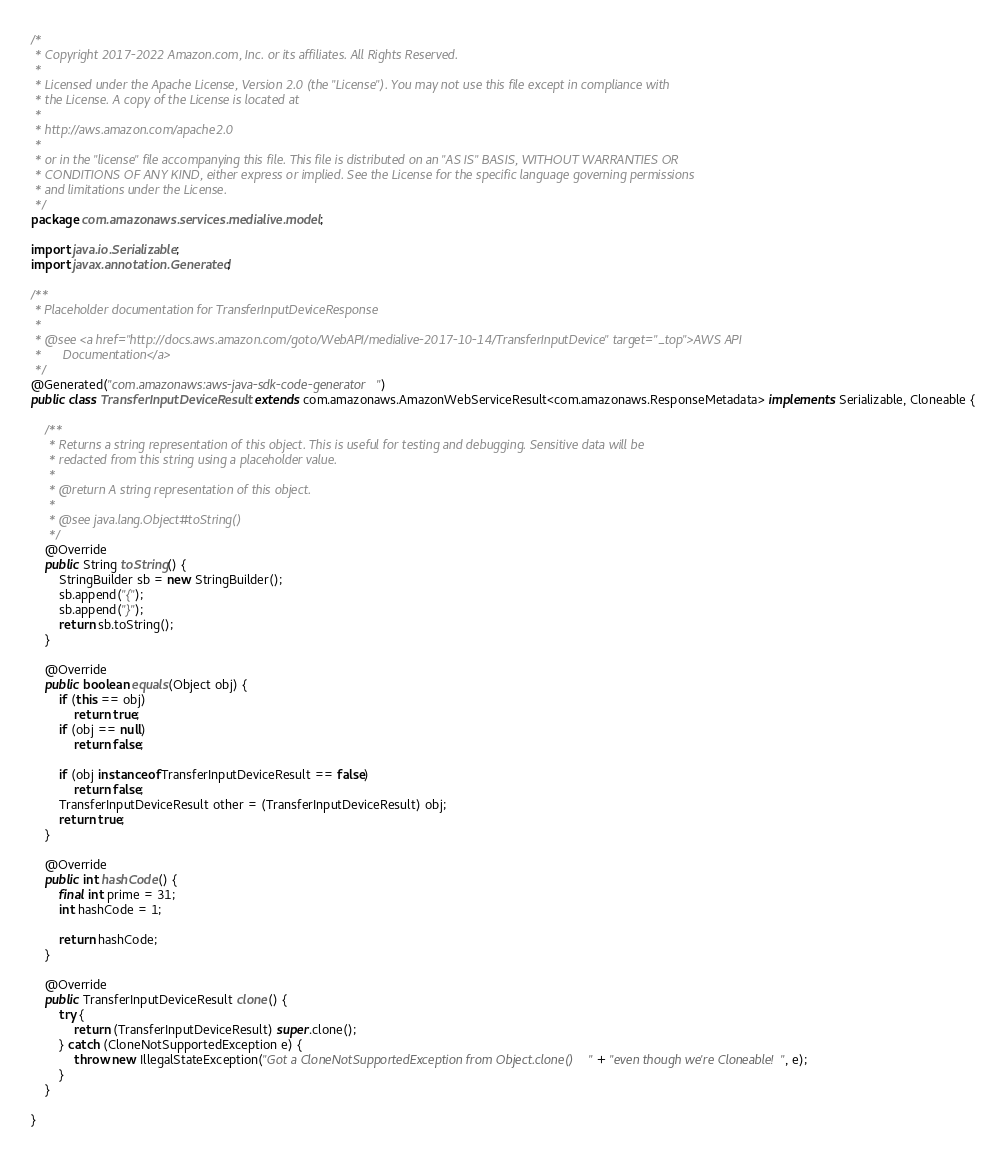<code> <loc_0><loc_0><loc_500><loc_500><_Java_>/*
 * Copyright 2017-2022 Amazon.com, Inc. or its affiliates. All Rights Reserved.
 * 
 * Licensed under the Apache License, Version 2.0 (the "License"). You may not use this file except in compliance with
 * the License. A copy of the License is located at
 * 
 * http://aws.amazon.com/apache2.0
 * 
 * or in the "license" file accompanying this file. This file is distributed on an "AS IS" BASIS, WITHOUT WARRANTIES OR
 * CONDITIONS OF ANY KIND, either express or implied. See the License for the specific language governing permissions
 * and limitations under the License.
 */
package com.amazonaws.services.medialive.model;

import java.io.Serializable;
import javax.annotation.Generated;

/**
 * Placeholder documentation for TransferInputDeviceResponse
 * 
 * @see <a href="http://docs.aws.amazon.com/goto/WebAPI/medialive-2017-10-14/TransferInputDevice" target="_top">AWS API
 *      Documentation</a>
 */
@Generated("com.amazonaws:aws-java-sdk-code-generator")
public class TransferInputDeviceResult extends com.amazonaws.AmazonWebServiceResult<com.amazonaws.ResponseMetadata> implements Serializable, Cloneable {

    /**
     * Returns a string representation of this object. This is useful for testing and debugging. Sensitive data will be
     * redacted from this string using a placeholder value.
     *
     * @return A string representation of this object.
     *
     * @see java.lang.Object#toString()
     */
    @Override
    public String toString() {
        StringBuilder sb = new StringBuilder();
        sb.append("{");
        sb.append("}");
        return sb.toString();
    }

    @Override
    public boolean equals(Object obj) {
        if (this == obj)
            return true;
        if (obj == null)
            return false;

        if (obj instanceof TransferInputDeviceResult == false)
            return false;
        TransferInputDeviceResult other = (TransferInputDeviceResult) obj;
        return true;
    }

    @Override
    public int hashCode() {
        final int prime = 31;
        int hashCode = 1;

        return hashCode;
    }

    @Override
    public TransferInputDeviceResult clone() {
        try {
            return (TransferInputDeviceResult) super.clone();
        } catch (CloneNotSupportedException e) {
            throw new IllegalStateException("Got a CloneNotSupportedException from Object.clone() " + "even though we're Cloneable!", e);
        }
    }

}
</code> 